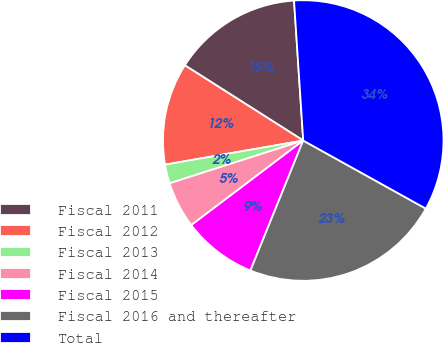Convert chart to OTSL. <chart><loc_0><loc_0><loc_500><loc_500><pie_chart><fcel>Fiscal 2011<fcel>Fiscal 2012<fcel>Fiscal 2013<fcel>Fiscal 2014<fcel>Fiscal 2015<fcel>Fiscal 2016 and thereafter<fcel>Total<nl><fcel>14.95%<fcel>11.76%<fcel>2.18%<fcel>5.37%<fcel>8.56%<fcel>23.07%<fcel>34.11%<nl></chart> 